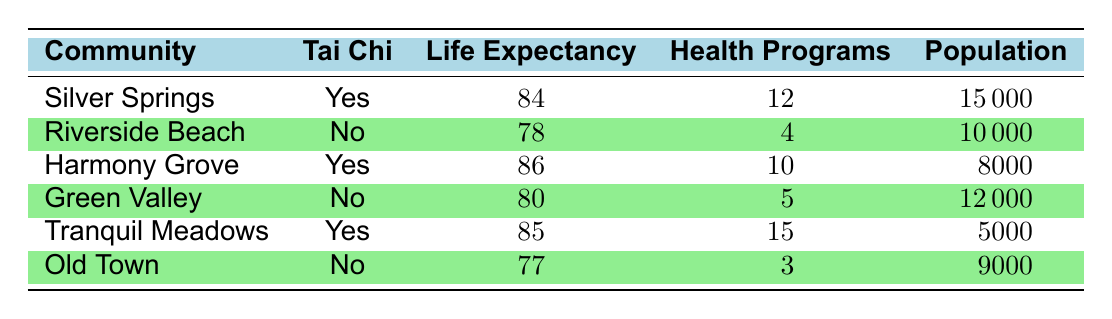What is the average life expectancy in communities practicing tai chi? The life expectancies for communities practicing tai chi are 84 (Silver Springs), 86 (Harmony Grove), and 85 (Tranquil Meadows). Adding these values gives 84 + 86 + 85 = 255. There are three data points, so we divide the total by 3 to get the average: 255 / 3 = 85.
Answer: 85 How many health programs are held yearly in Riverside Beach? The table explicitly shows that Riverside Beach has 4 yearly health programs.
Answer: 4 Is the average life expectancy in Harmony Grove higher than in Silver Springs? Harmony Grove has an average life expectancy of 86, while Silver Springs has an average of 84. Since 86 is greater than 84, the statement is true.
Answer: Yes What is the difference in average life expectancy between the community with the highest and the lowest expectancy? The highest life expectancy is in Harmony Grove (86) and the lowest is in Old Town (77). To find the difference, we subtract the lowest from the highest: 86 - 77 = 9.
Answer: 9 Do all communities practicing tai chi have more yearly health programs than those that do not? The communities practicing tai chi (Silver Springs, Harmony Grove, Tranquil Meadows) have 12, 10, and 15 health programs respectively, totaling 37. The communities not practicing tai chi (Riverside Beach, Green Valley, Old Town) have 4, 5, and 3 programs respectively, totaling 12. Since 37 is greater than 12, not all tai chi communities have more than those that do not.
Answer: No What is the total population of communities that do not practice tai chi? The communities not practicing tai chi are Riverside Beach (10,000), Green Valley (12,000), and Old Town (9,000). Adding these populations gives a total of 10,000 + 12,000 + 9,000 = 31,000.
Answer: 31000 How does the average life expectancy of communities practicing tai chi compare to that of those that do not? The average life expectancy for communities practicing tai chi is 85, while for non-practicing communities it's (78 + 80 + 77) / 3 = 235 / 3 = 78.33. Comparing these values, 85 is greater than 78.33.
Answer: Tai chi communities have higher life expectancy Which community has the highest life expectancy and what is that value? From the data, Harmony Grove has the highest life expectancy at 86. We can confirm this by reviewing the average life expectancies of all communities listed and identifying Harmony Grove as the highest.
Answer: 86 